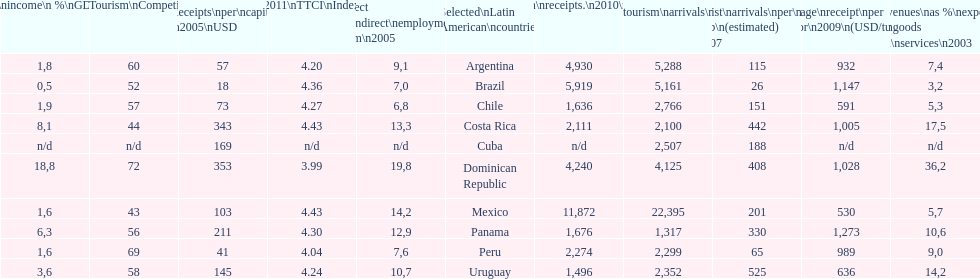What country makes the most tourist income? Dominican Republic. 